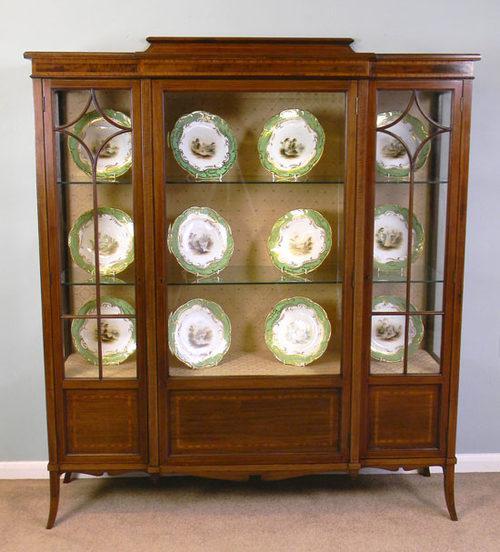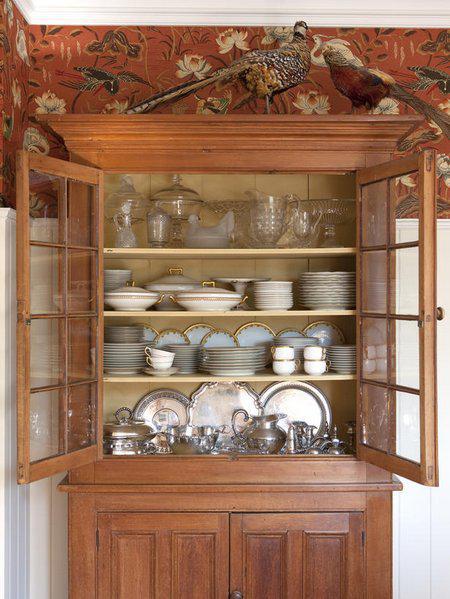The first image is the image on the left, the second image is the image on the right. Given the left and right images, does the statement "There is one hutch with doors open." hold true? Answer yes or no. Yes. The first image is the image on the left, the second image is the image on the right. Considering the images on both sides, is "There are four plates on each shelf in the image on the left" valid? Answer yes or no. Yes. 